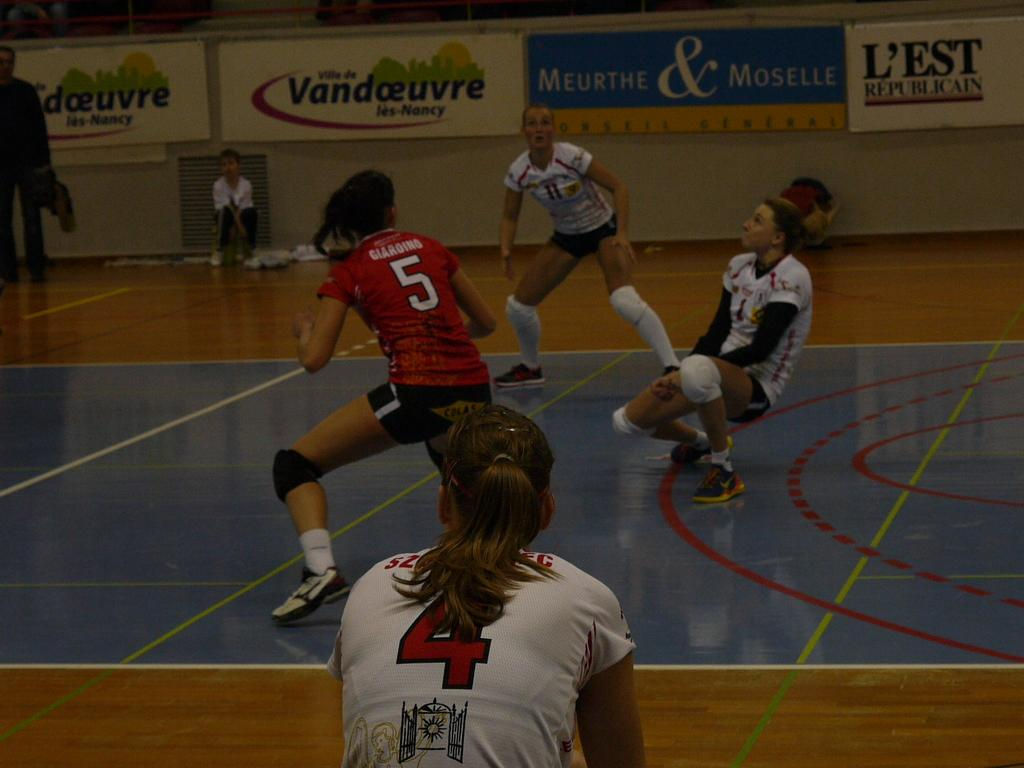What are the persons in the foreground of the image doing? There is a group of persons playing on the floor. Can you describe the background of the image? There are persons visible in the background, along with a wall and advertisements. What type of riddle can be seen on the plantation in the background of the image? There is no plantation or riddle present in the image. What type of harmony is being demonstrated by the persons in the image? The image does not specifically depict harmony, but it shows a group of persons playing together. 